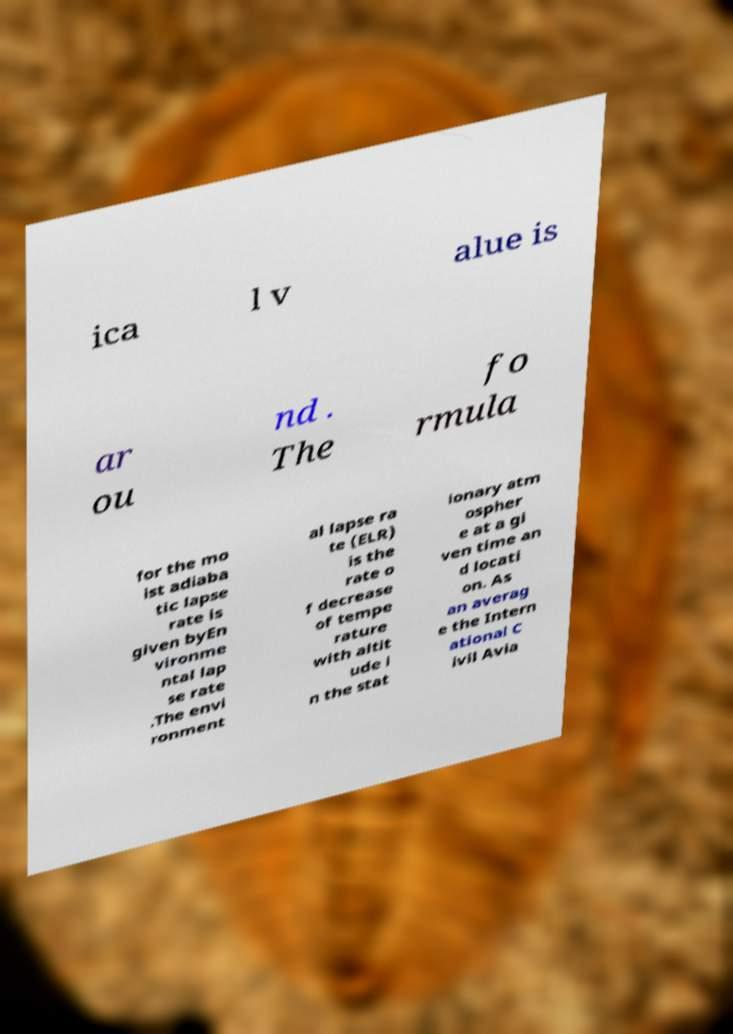Can you read and provide the text displayed in the image?This photo seems to have some interesting text. Can you extract and type it out for me? ica l v alue is ar ou nd . The fo rmula for the mo ist adiaba tic lapse rate is given byEn vironme ntal lap se rate .The envi ronment al lapse ra te (ELR) is the rate o f decrease of tempe rature with altit ude i n the stat ionary atm ospher e at a gi ven time an d locati on. As an averag e the Intern ational C ivil Avia 